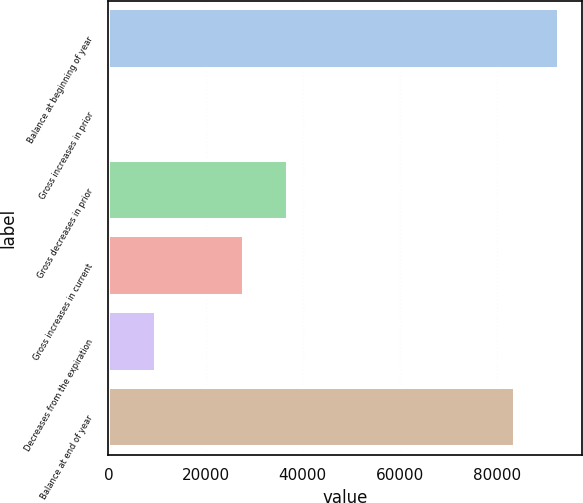Convert chart to OTSL. <chart><loc_0><loc_0><loc_500><loc_500><bar_chart><fcel>Balance at beginning of year<fcel>Gross increases in prior<fcel>Gross decreases in prior<fcel>Gross increases in current<fcel>Decreases from the expiration<fcel>Balance at end of year<nl><fcel>92843.8<fcel>811<fcel>36939.8<fcel>27910<fcel>9840.8<fcel>83814<nl></chart> 